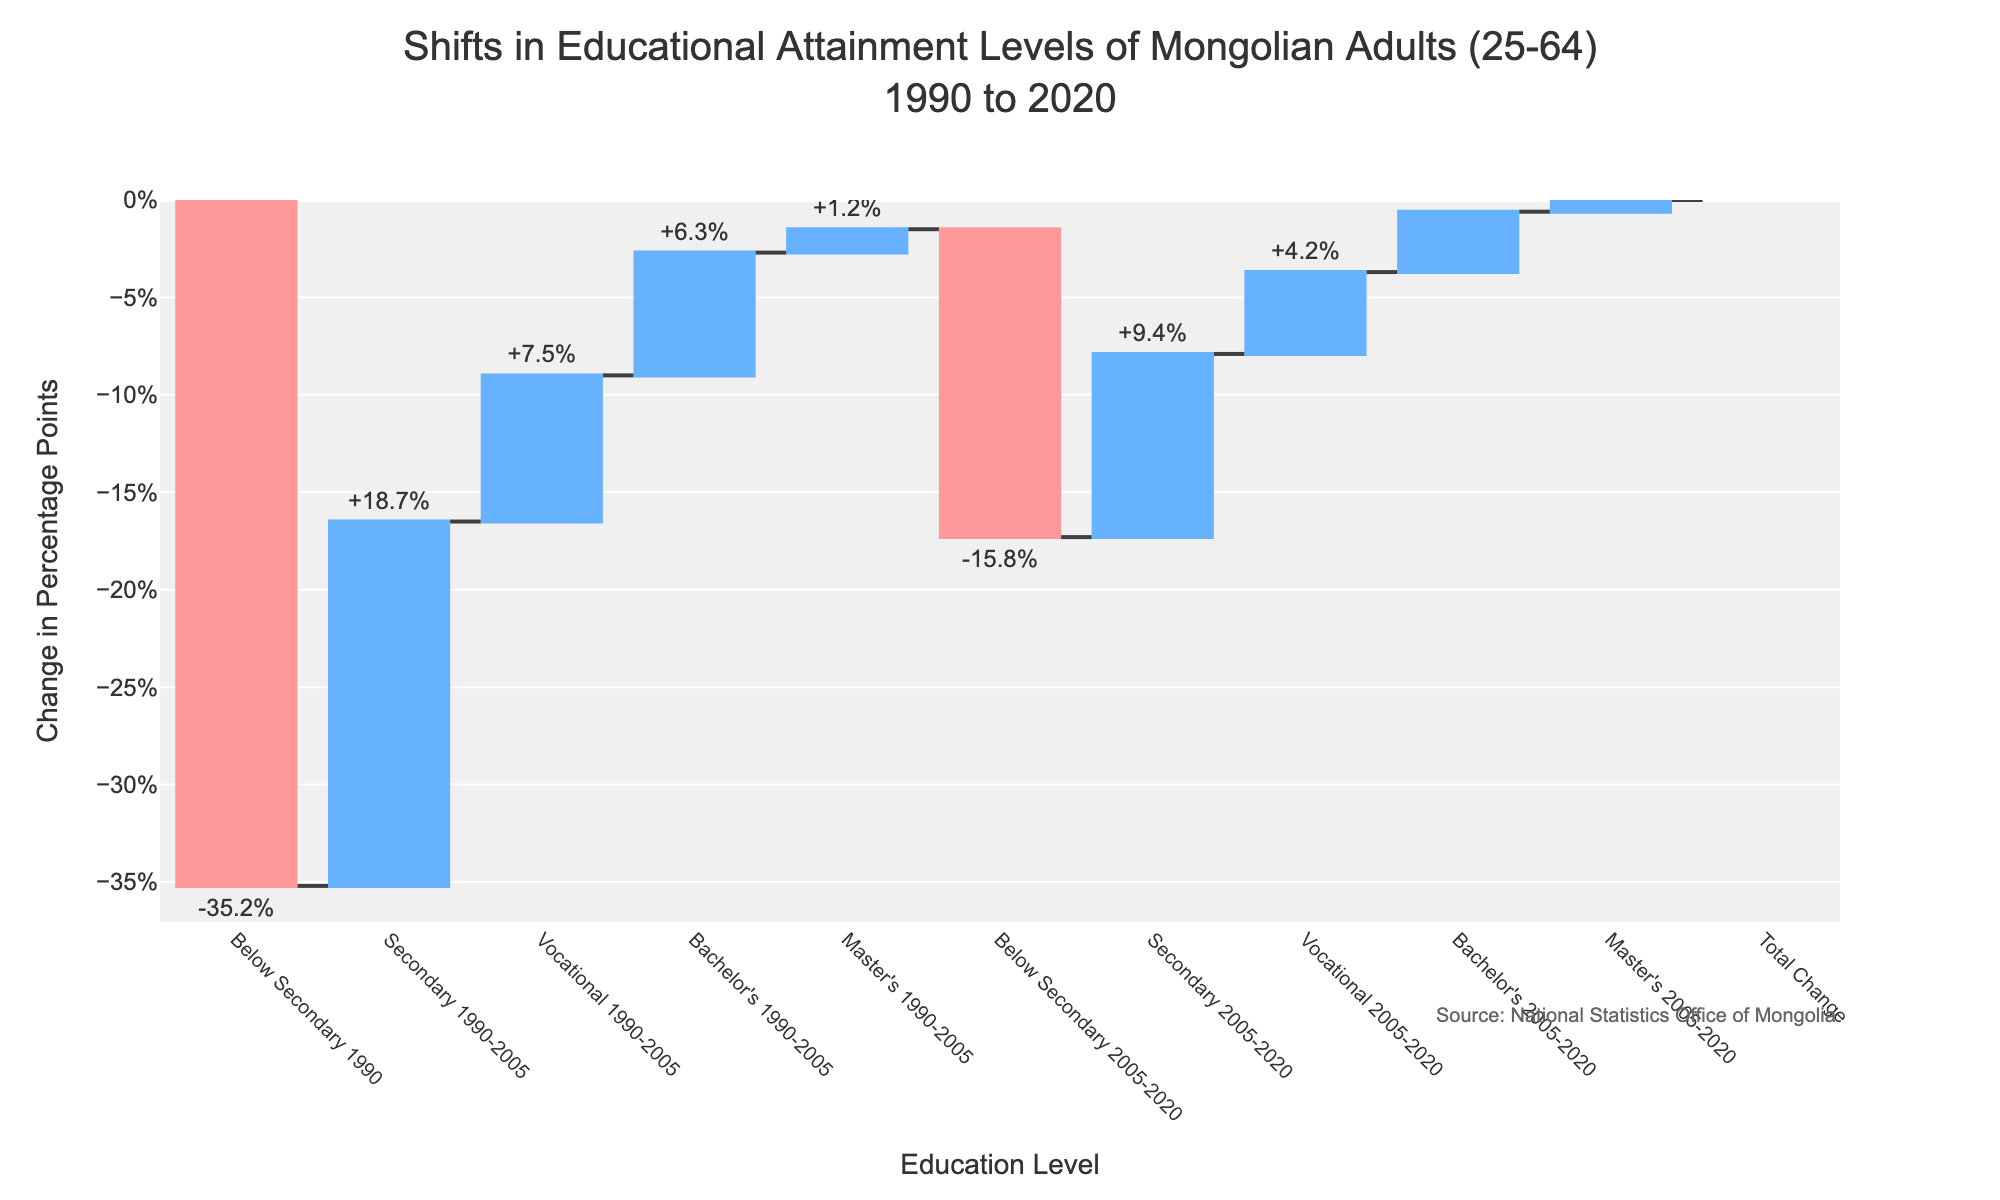What is the title of the figure? The title is at the top of the figure. It reads: "Shifts in Educational Attainment Levels of Mongolian Adults (25-64) 1990 to 2020"
Answer: Shifts in Educational Attainment Levels of Mongolian Adults (25-64) 1990 to 2020 What color represents an increase in educational attainment levels? The color for an increase is consistent throughout the figure. It's a shade of blue.
Answer: Blue How much did the percentage of adults with Below Secondary education decrease from 1990 to 2005? The segment for Below Secondary 1990-2005 shows a decrease, indicated by a negative value. It decreased by 35.2 percentage points.
Answer: 35.2% Which educational level saw the smallest increase from 2005 to 2020? Look at the segments from 2005 to 2020. The smallest increase is in the Master’s category, which increased by 0.6 percentage points.
Answer: Master’s What is the total percentage change across all educational levels from 1990 to 2020? The total change is indicated at the end of the figure. The total change is 0 percentage points.
Answer: 0% How does the increase in Secondary educational attainment from 1990 to 2005 compare to the increase from 2005 to 2020? Compare the values for Secondary education in both periods. From 1990 to 2005, it increased by 18.7, and from 2005 to 2020, it increased by 9.4. The increase from 1990 to 2005 is greater.
Answer: Increase from 1990-2005 is greater Which periods show a decrease in Below Secondary education levels? Identify periods with negative values for Below Secondary education. Both 1990-2005 (-35.2) and 2005-2020 (-15.8) show decreases.
Answer: 1990-2005, 2005-2020 Calculate the combined increase in Vocational and Bachelor's educational levels from 1990 to 2020. Sum the values for Vocational (7.5, 4.2) and Bachelor's (6.3, 3.1). Combined increase is 7.5 + 4.2 + 6.3 + 3.1 = 21.1 percentage points.
Answer: 21.1% Which educational category had the greatest increase between 1990 and 2005? Among the positive values for 1990-2005, Secondary education has the greatest increase of 18.7 percentage points.
Answer: Secondary What is the change in percentage points for Master's education from 1990 to 2005 compared to 2005 to 2020? Compare the values for Master's education. From 1990 to 2005, it increased by 1.2, and from 2005 to 2020, it increased by 0.6. The change from 1990 to 2005 is twice that of 2005 to 2020.
Answer: 1.2 vs 0.6 